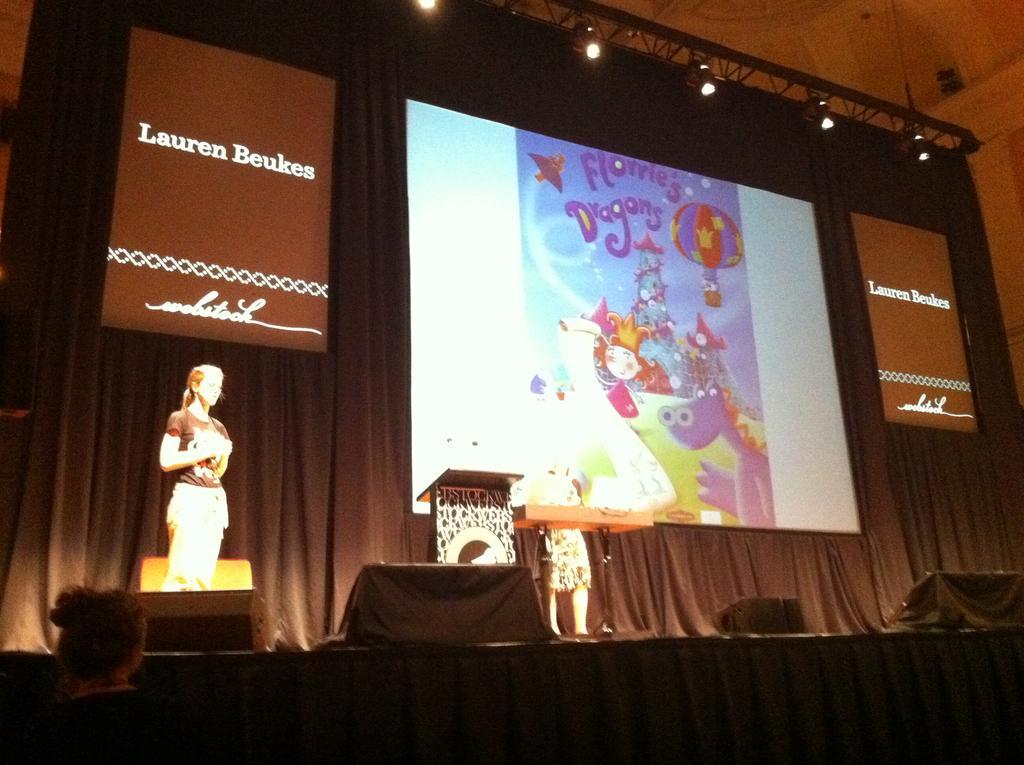Describe this image in one or two sentences. In the image we can see there are people standing on the stage and there is a mic kept on the podium. Behind there is a projector screen and there is a banner. There are speaker boxes kept on the stage and there is a person standing on the ground. 